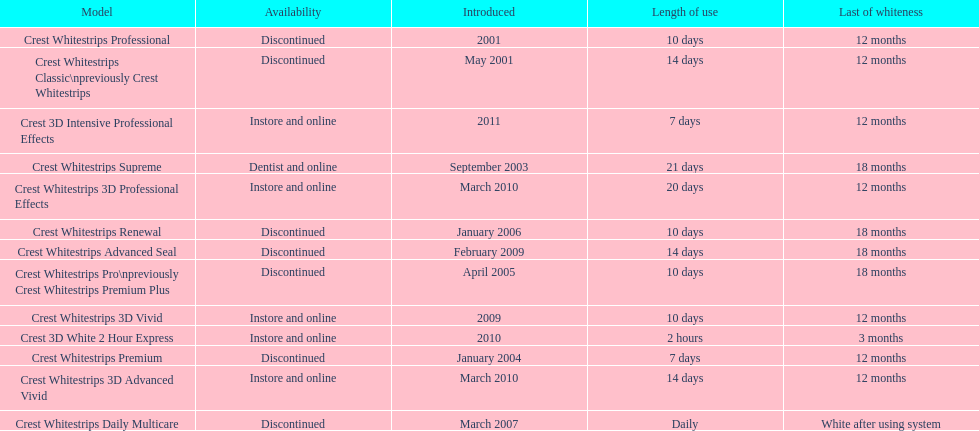What product was introduced in the same month as crest whitestrips 3d advanced vivid? Crest Whitestrips 3D Professional Effects. 